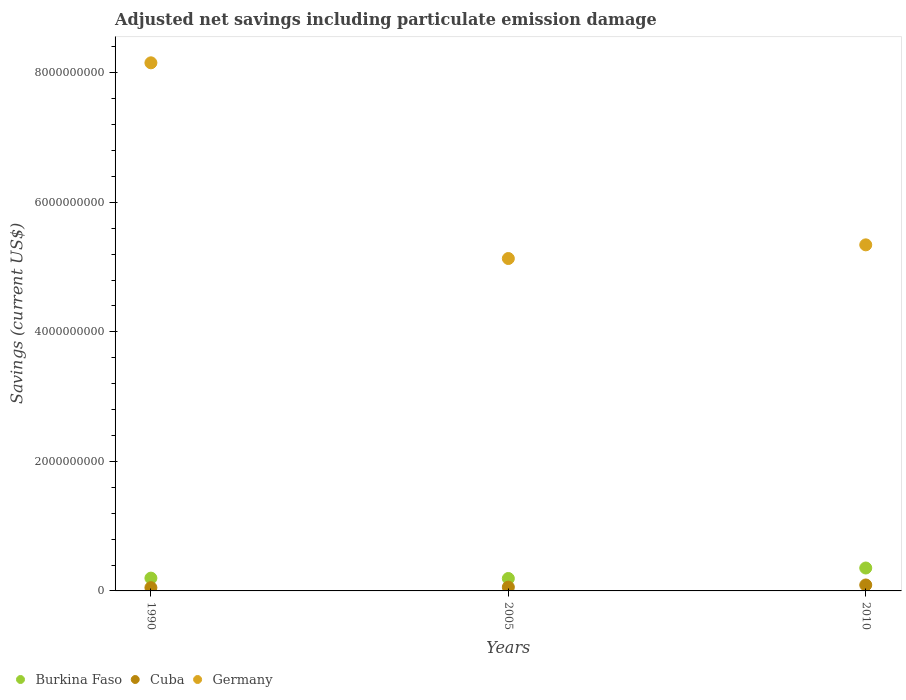How many different coloured dotlines are there?
Make the answer very short. 3. What is the net savings in Cuba in 2010?
Provide a short and direct response. 9.18e+07. Across all years, what is the maximum net savings in Cuba?
Offer a very short reply. 9.18e+07. Across all years, what is the minimum net savings in Burkina Faso?
Your answer should be very brief. 1.92e+08. In which year was the net savings in Germany minimum?
Give a very brief answer. 2005. What is the total net savings in Germany in the graph?
Keep it short and to the point. 1.86e+1. What is the difference between the net savings in Cuba in 2005 and that in 2010?
Your response must be concise. -3.35e+07. What is the difference between the net savings in Germany in 2005 and the net savings in Cuba in 1990?
Your response must be concise. 5.08e+09. What is the average net savings in Germany per year?
Provide a short and direct response. 6.21e+09. In the year 2010, what is the difference between the net savings in Germany and net savings in Burkina Faso?
Offer a very short reply. 4.99e+09. In how many years, is the net savings in Cuba greater than 7600000000 US$?
Your answer should be very brief. 0. What is the ratio of the net savings in Burkina Faso in 1990 to that in 2005?
Your answer should be compact. 1.03. Is the difference between the net savings in Germany in 1990 and 2010 greater than the difference between the net savings in Burkina Faso in 1990 and 2010?
Offer a very short reply. Yes. What is the difference between the highest and the second highest net savings in Cuba?
Your response must be concise. 3.35e+07. What is the difference between the highest and the lowest net savings in Germany?
Offer a terse response. 3.02e+09. In how many years, is the net savings in Germany greater than the average net savings in Germany taken over all years?
Ensure brevity in your answer.  1. Is the sum of the net savings in Cuba in 1990 and 2005 greater than the maximum net savings in Burkina Faso across all years?
Provide a succinct answer. No. Does the net savings in Burkina Faso monotonically increase over the years?
Offer a very short reply. No. Is the net savings in Cuba strictly greater than the net savings in Germany over the years?
Provide a short and direct response. No. How many dotlines are there?
Provide a succinct answer. 3. How many years are there in the graph?
Give a very brief answer. 3. What is the difference between two consecutive major ticks on the Y-axis?
Your answer should be compact. 2.00e+09. Are the values on the major ticks of Y-axis written in scientific E-notation?
Your answer should be compact. No. Does the graph contain any zero values?
Provide a short and direct response. No. How many legend labels are there?
Offer a terse response. 3. What is the title of the graph?
Give a very brief answer. Adjusted net savings including particulate emission damage. Does "Europe(developing only)" appear as one of the legend labels in the graph?
Ensure brevity in your answer.  No. What is the label or title of the Y-axis?
Your answer should be very brief. Savings (current US$). What is the Savings (current US$) of Burkina Faso in 1990?
Provide a succinct answer. 1.98e+08. What is the Savings (current US$) of Cuba in 1990?
Keep it short and to the point. 5.03e+07. What is the Savings (current US$) in Germany in 1990?
Your answer should be very brief. 8.15e+09. What is the Savings (current US$) of Burkina Faso in 2005?
Offer a very short reply. 1.92e+08. What is the Savings (current US$) in Cuba in 2005?
Your response must be concise. 5.83e+07. What is the Savings (current US$) of Germany in 2005?
Your response must be concise. 5.13e+09. What is the Savings (current US$) in Burkina Faso in 2010?
Your answer should be very brief. 3.54e+08. What is the Savings (current US$) in Cuba in 2010?
Your answer should be very brief. 9.18e+07. What is the Savings (current US$) of Germany in 2010?
Provide a succinct answer. 5.34e+09. Across all years, what is the maximum Savings (current US$) in Burkina Faso?
Keep it short and to the point. 3.54e+08. Across all years, what is the maximum Savings (current US$) in Cuba?
Provide a short and direct response. 9.18e+07. Across all years, what is the maximum Savings (current US$) of Germany?
Provide a succinct answer. 8.15e+09. Across all years, what is the minimum Savings (current US$) in Burkina Faso?
Give a very brief answer. 1.92e+08. Across all years, what is the minimum Savings (current US$) of Cuba?
Your answer should be compact. 5.03e+07. Across all years, what is the minimum Savings (current US$) in Germany?
Ensure brevity in your answer.  5.13e+09. What is the total Savings (current US$) of Burkina Faso in the graph?
Provide a short and direct response. 7.43e+08. What is the total Savings (current US$) of Cuba in the graph?
Your response must be concise. 2.00e+08. What is the total Savings (current US$) in Germany in the graph?
Your answer should be very brief. 1.86e+1. What is the difference between the Savings (current US$) in Burkina Faso in 1990 and that in 2005?
Provide a succinct answer. 5.55e+06. What is the difference between the Savings (current US$) of Cuba in 1990 and that in 2005?
Provide a succinct answer. -7.99e+06. What is the difference between the Savings (current US$) of Germany in 1990 and that in 2005?
Provide a short and direct response. 3.02e+09. What is the difference between the Savings (current US$) of Burkina Faso in 1990 and that in 2010?
Give a very brief answer. -1.56e+08. What is the difference between the Savings (current US$) of Cuba in 1990 and that in 2010?
Offer a terse response. -4.15e+07. What is the difference between the Savings (current US$) in Germany in 1990 and that in 2010?
Offer a very short reply. 2.81e+09. What is the difference between the Savings (current US$) in Burkina Faso in 2005 and that in 2010?
Ensure brevity in your answer.  -1.62e+08. What is the difference between the Savings (current US$) in Cuba in 2005 and that in 2010?
Ensure brevity in your answer.  -3.35e+07. What is the difference between the Savings (current US$) of Germany in 2005 and that in 2010?
Ensure brevity in your answer.  -2.11e+08. What is the difference between the Savings (current US$) of Burkina Faso in 1990 and the Savings (current US$) of Cuba in 2005?
Ensure brevity in your answer.  1.39e+08. What is the difference between the Savings (current US$) in Burkina Faso in 1990 and the Savings (current US$) in Germany in 2005?
Your response must be concise. -4.93e+09. What is the difference between the Savings (current US$) in Cuba in 1990 and the Savings (current US$) in Germany in 2005?
Keep it short and to the point. -5.08e+09. What is the difference between the Savings (current US$) in Burkina Faso in 1990 and the Savings (current US$) in Cuba in 2010?
Offer a very short reply. 1.06e+08. What is the difference between the Savings (current US$) of Burkina Faso in 1990 and the Savings (current US$) of Germany in 2010?
Provide a short and direct response. -5.15e+09. What is the difference between the Savings (current US$) in Cuba in 1990 and the Savings (current US$) in Germany in 2010?
Provide a succinct answer. -5.29e+09. What is the difference between the Savings (current US$) in Burkina Faso in 2005 and the Savings (current US$) in Cuba in 2010?
Your response must be concise. 1.00e+08. What is the difference between the Savings (current US$) in Burkina Faso in 2005 and the Savings (current US$) in Germany in 2010?
Offer a very short reply. -5.15e+09. What is the difference between the Savings (current US$) of Cuba in 2005 and the Savings (current US$) of Germany in 2010?
Ensure brevity in your answer.  -5.29e+09. What is the average Savings (current US$) of Burkina Faso per year?
Make the answer very short. 2.48e+08. What is the average Savings (current US$) of Cuba per year?
Your answer should be compact. 6.68e+07. What is the average Savings (current US$) in Germany per year?
Offer a terse response. 6.21e+09. In the year 1990, what is the difference between the Savings (current US$) in Burkina Faso and Savings (current US$) in Cuba?
Offer a terse response. 1.47e+08. In the year 1990, what is the difference between the Savings (current US$) of Burkina Faso and Savings (current US$) of Germany?
Offer a terse response. -7.96e+09. In the year 1990, what is the difference between the Savings (current US$) of Cuba and Savings (current US$) of Germany?
Your response must be concise. -8.10e+09. In the year 2005, what is the difference between the Savings (current US$) of Burkina Faso and Savings (current US$) of Cuba?
Your answer should be very brief. 1.34e+08. In the year 2005, what is the difference between the Savings (current US$) of Burkina Faso and Savings (current US$) of Germany?
Make the answer very short. -4.94e+09. In the year 2005, what is the difference between the Savings (current US$) of Cuba and Savings (current US$) of Germany?
Provide a succinct answer. -5.07e+09. In the year 2010, what is the difference between the Savings (current US$) of Burkina Faso and Savings (current US$) of Cuba?
Keep it short and to the point. 2.62e+08. In the year 2010, what is the difference between the Savings (current US$) in Burkina Faso and Savings (current US$) in Germany?
Provide a succinct answer. -4.99e+09. In the year 2010, what is the difference between the Savings (current US$) of Cuba and Savings (current US$) of Germany?
Your answer should be very brief. -5.25e+09. What is the ratio of the Savings (current US$) in Burkina Faso in 1990 to that in 2005?
Keep it short and to the point. 1.03. What is the ratio of the Savings (current US$) in Cuba in 1990 to that in 2005?
Provide a succinct answer. 0.86. What is the ratio of the Savings (current US$) in Germany in 1990 to that in 2005?
Your answer should be compact. 1.59. What is the ratio of the Savings (current US$) of Burkina Faso in 1990 to that in 2010?
Provide a succinct answer. 0.56. What is the ratio of the Savings (current US$) of Cuba in 1990 to that in 2010?
Make the answer very short. 0.55. What is the ratio of the Savings (current US$) of Germany in 1990 to that in 2010?
Offer a very short reply. 1.53. What is the ratio of the Savings (current US$) of Burkina Faso in 2005 to that in 2010?
Offer a terse response. 0.54. What is the ratio of the Savings (current US$) in Cuba in 2005 to that in 2010?
Offer a terse response. 0.64. What is the ratio of the Savings (current US$) of Germany in 2005 to that in 2010?
Keep it short and to the point. 0.96. What is the difference between the highest and the second highest Savings (current US$) in Burkina Faso?
Make the answer very short. 1.56e+08. What is the difference between the highest and the second highest Savings (current US$) of Cuba?
Give a very brief answer. 3.35e+07. What is the difference between the highest and the second highest Savings (current US$) of Germany?
Your answer should be compact. 2.81e+09. What is the difference between the highest and the lowest Savings (current US$) in Burkina Faso?
Provide a short and direct response. 1.62e+08. What is the difference between the highest and the lowest Savings (current US$) in Cuba?
Offer a terse response. 4.15e+07. What is the difference between the highest and the lowest Savings (current US$) of Germany?
Keep it short and to the point. 3.02e+09. 